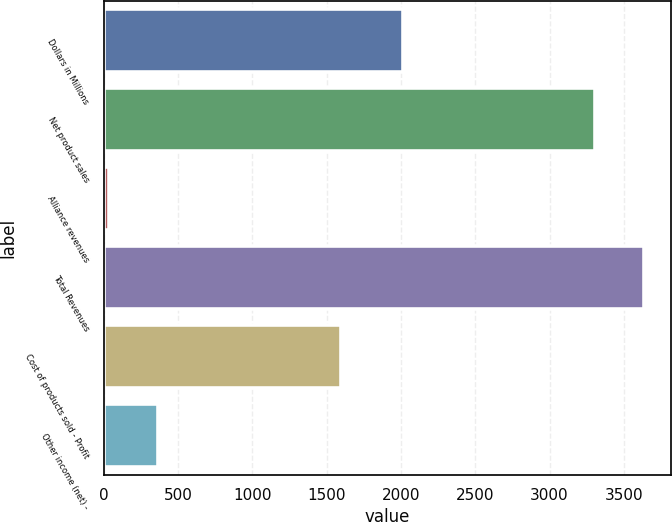Convert chart. <chart><loc_0><loc_0><loc_500><loc_500><bar_chart><fcel>Dollars in Millions<fcel>Net product sales<fcel>Alliance revenues<fcel>Total Revenues<fcel>Cost of products sold - Profit<fcel>Other income (net) -<nl><fcel>2016<fcel>3306<fcel>37<fcel>3636.6<fcel>1595<fcel>367.6<nl></chart> 